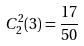Convert formula to latex. <formula><loc_0><loc_0><loc_500><loc_500>C _ { 2 } ^ { 2 } ( 3 ) = \frac { 1 7 } { 5 0 }</formula> 